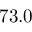<formula> <loc_0><loc_0><loc_500><loc_500>7 3 . 0</formula> 